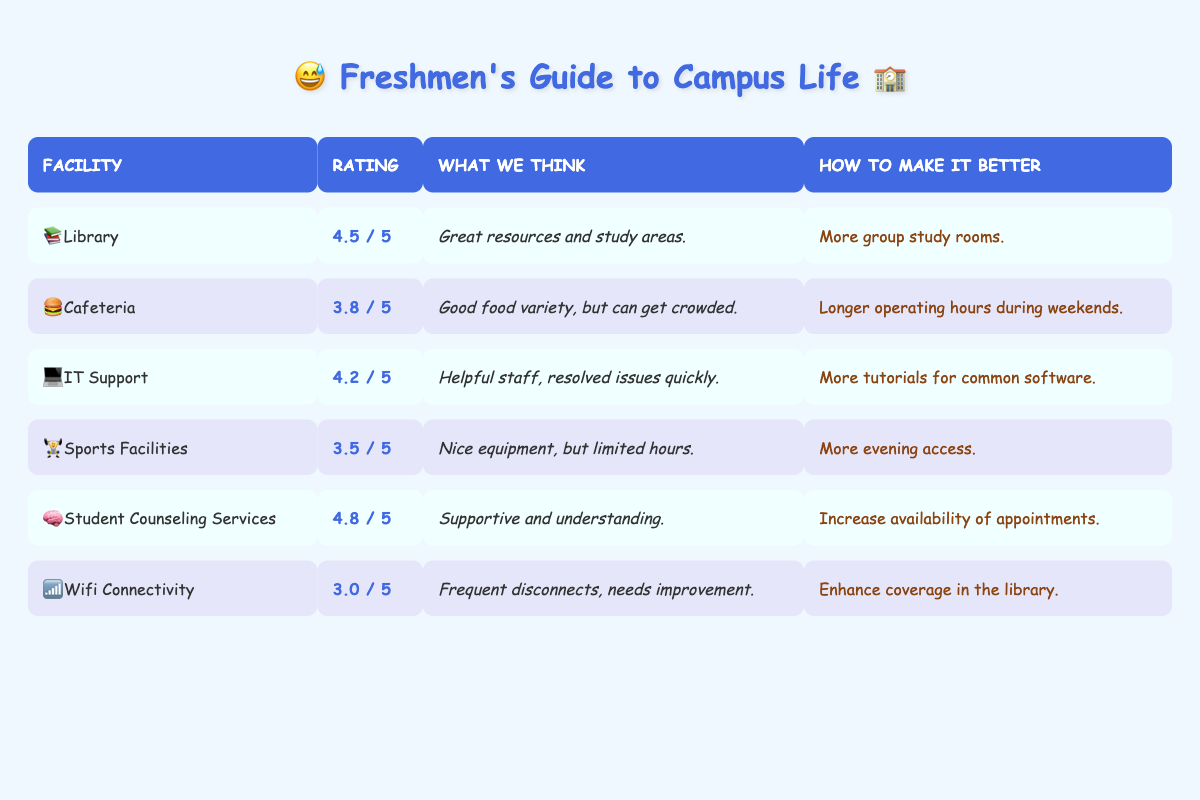What is the satisfaction rating for the Library? The satisfaction rating for the Library is listed in the table under the "Rating" column next to the "Library" row, which is 4.5.
Answer: 4.5 What are the suggestions for improving the Cafeteria? The suggestions for improving the Cafeteria are found in the "How to Make It Better" column next to "Cafeteria," which states "Longer operating hours during weekends."
Answer: Longer operating hours during weekends Is the satisfaction rating for Wifi Connectivity higher than 3? The satisfaction rating for Wifi Connectivity is listed as 3.0 in the "Rating" column, which is not higher than 3. Therefore, the answer is no.
Answer: No What is the average satisfaction rating for the facilities listed in the table? To find the average, add the satisfaction ratings: (4.5 + 3.8 + 4.2 + 3.5 + 4.8 + 3.0) = 23.8. Then divide by the number of facilities, which is 6. The average is 23.8 / 6 = 3.97.
Answer: 3.97 Which facility received the highest satisfaction rating? By looking through the "Rating" column, Student Counseling Services has the highest rating at 4.8.
Answer: Student Counseling Services How many facilities have a satisfaction rating of 4 or above? First, identify the ratings of each facility: Library (4.5), Cafeteria (3.8), IT Support (4.2), Sports Facilities (3.5), Student Counseling Services (4.8), and Wifi Connectivity (3.0). The facilities with ratings of 4 or above are Library, IT Support, and Student Counseling Services, totaling 3 facilities.
Answer: 3 What is the suggested improvement for the IT Support department? The suggested improvement for IT Support is found in the row for IT Support under "How to Make It Better," which states "More tutorials for common software."
Answer: More tutorials for common software Is the Sports Facilities satisfaction rating less than the average rating calculated earlier? The average rating calculated earlier is approximately 3.97. The Sports Facilities rating is 3.5, which is indeed less than 3.97. Therefore, the answer is yes.
Answer: Yes What is the difference between the highest and lowest satisfaction ratings? The highest satisfaction rating is for Student Counseling Services at 4.8, while the lowest is for Wifi Connectivity at 3.0. The difference is calculated as 4.8 - 3.0 = 1.8.
Answer: 1.8 